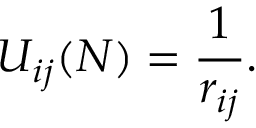Convert formula to latex. <formula><loc_0><loc_0><loc_500><loc_500>U _ { i j } ( N ) = { \frac { 1 } { r _ { i j } } } .</formula> 